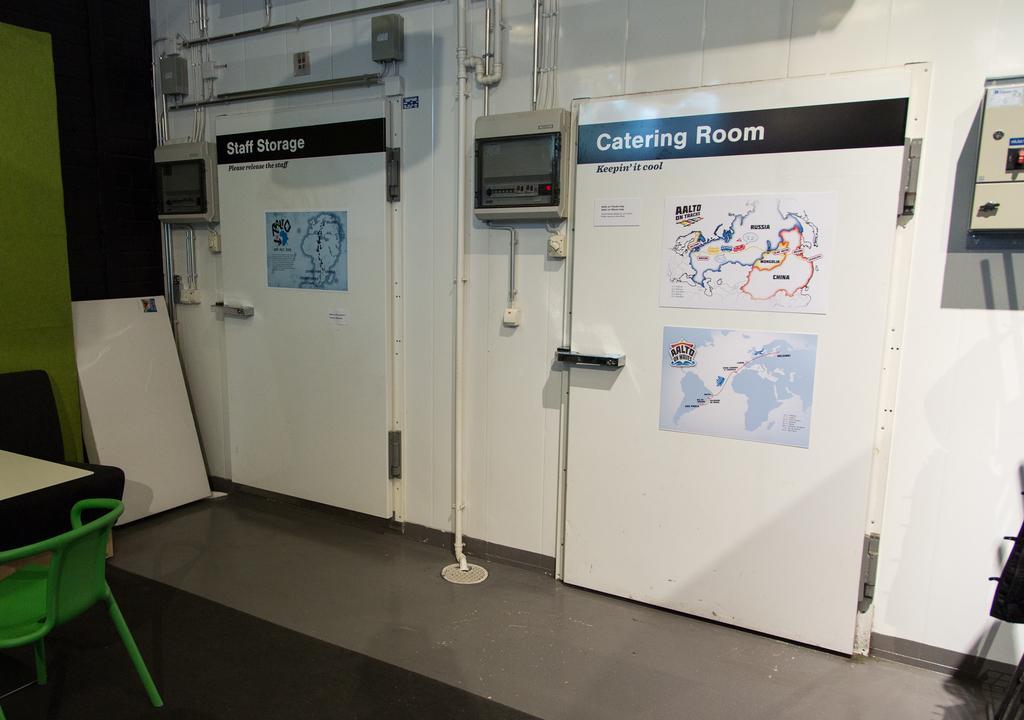How would you summarize this image in a sentence or two? In this image I can see inside view of a room , on the left side I can see a table and green color chair and I can see the wall in the middle , on the wall I can see the hoarding board and a machine , pipe line attached to the wall in the middle. 